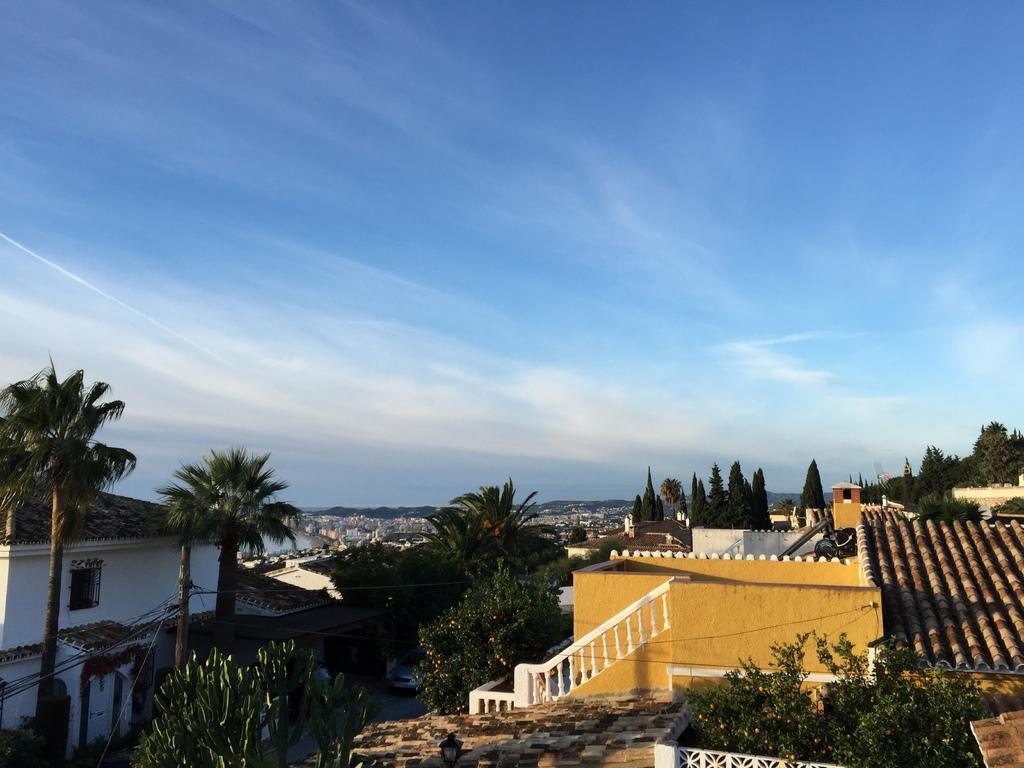Can you describe this image briefly? We can see buildings, plants, trees, light, car on the road and pole with wires. In the background we can see sky with clouds. 